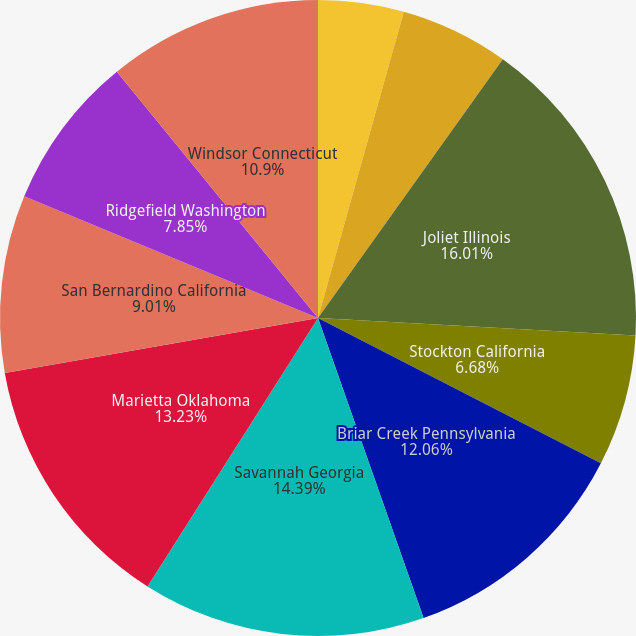Convert chart to OTSL. <chart><loc_0><loc_0><loc_500><loc_500><pie_chart><fcel>Chesapeake Virginia<fcel>Olive Branch Mississippi<fcel>Joliet Illinois<fcel>Stockton California<fcel>Briar Creek Pennsylvania<fcel>Savannah Georgia<fcel>Marietta Oklahoma<fcel>San Bernardino California<fcel>Ridgefield Washington<fcel>Windsor Connecticut<nl><fcel>4.35%<fcel>5.52%<fcel>16.0%<fcel>6.68%<fcel>12.06%<fcel>14.39%<fcel>13.23%<fcel>9.01%<fcel>7.85%<fcel>10.9%<nl></chart> 